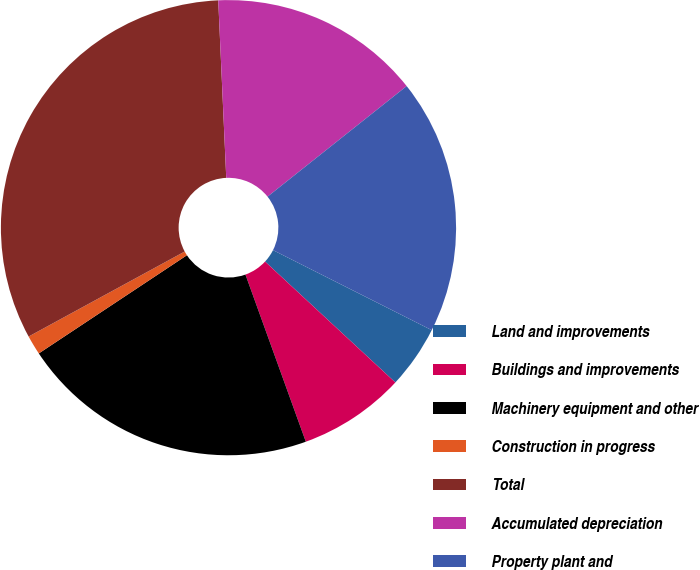Convert chart to OTSL. <chart><loc_0><loc_0><loc_500><loc_500><pie_chart><fcel>Land and improvements<fcel>Buildings and improvements<fcel>Machinery equipment and other<fcel>Construction in progress<fcel>Total<fcel>Accumulated depreciation<fcel>Property plant and<nl><fcel>4.47%<fcel>7.58%<fcel>21.2%<fcel>1.38%<fcel>32.22%<fcel>15.03%<fcel>18.12%<nl></chart> 